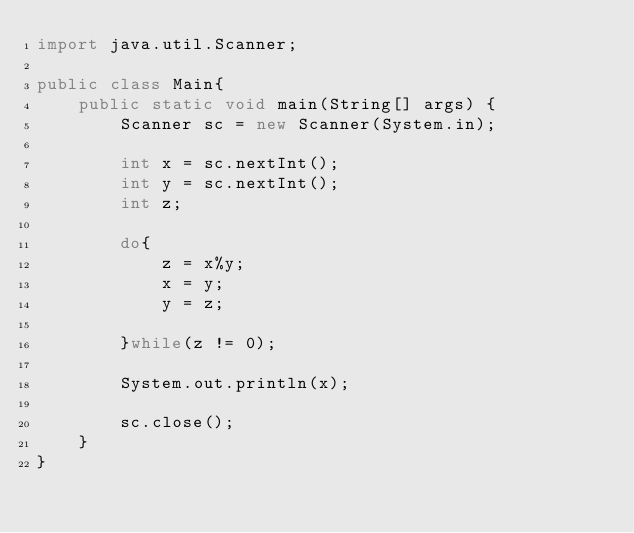Convert code to text. <code><loc_0><loc_0><loc_500><loc_500><_Java_>import java.util.Scanner;

public class Main{
    public static void main(String[] args) {
        Scanner sc = new Scanner(System.in);

        int x = sc.nextInt();
        int y = sc.nextInt();
        int z;

        do{
            z = x%y;
            x = y;
            y = z;

        }while(z != 0);

        System.out.println(x);

        sc.close();
    }
}
</code> 